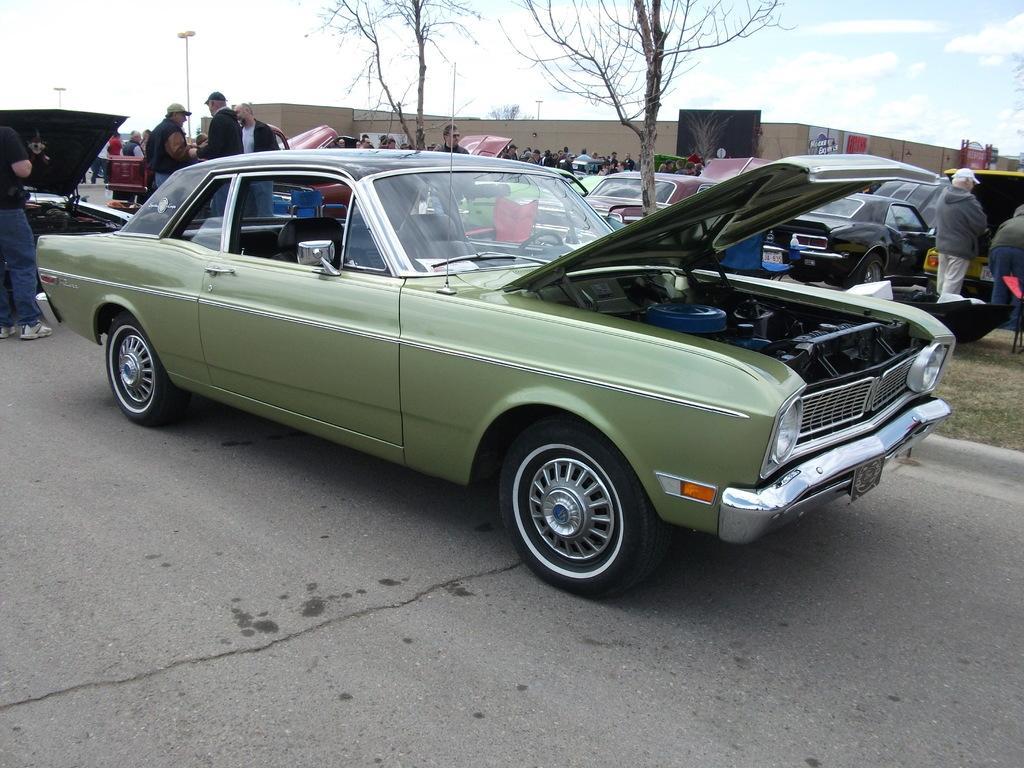Can you describe this image briefly? In this picture there is a car in the center of the image and there are cars, people, posters, poles, and trees in the background area of the image. 